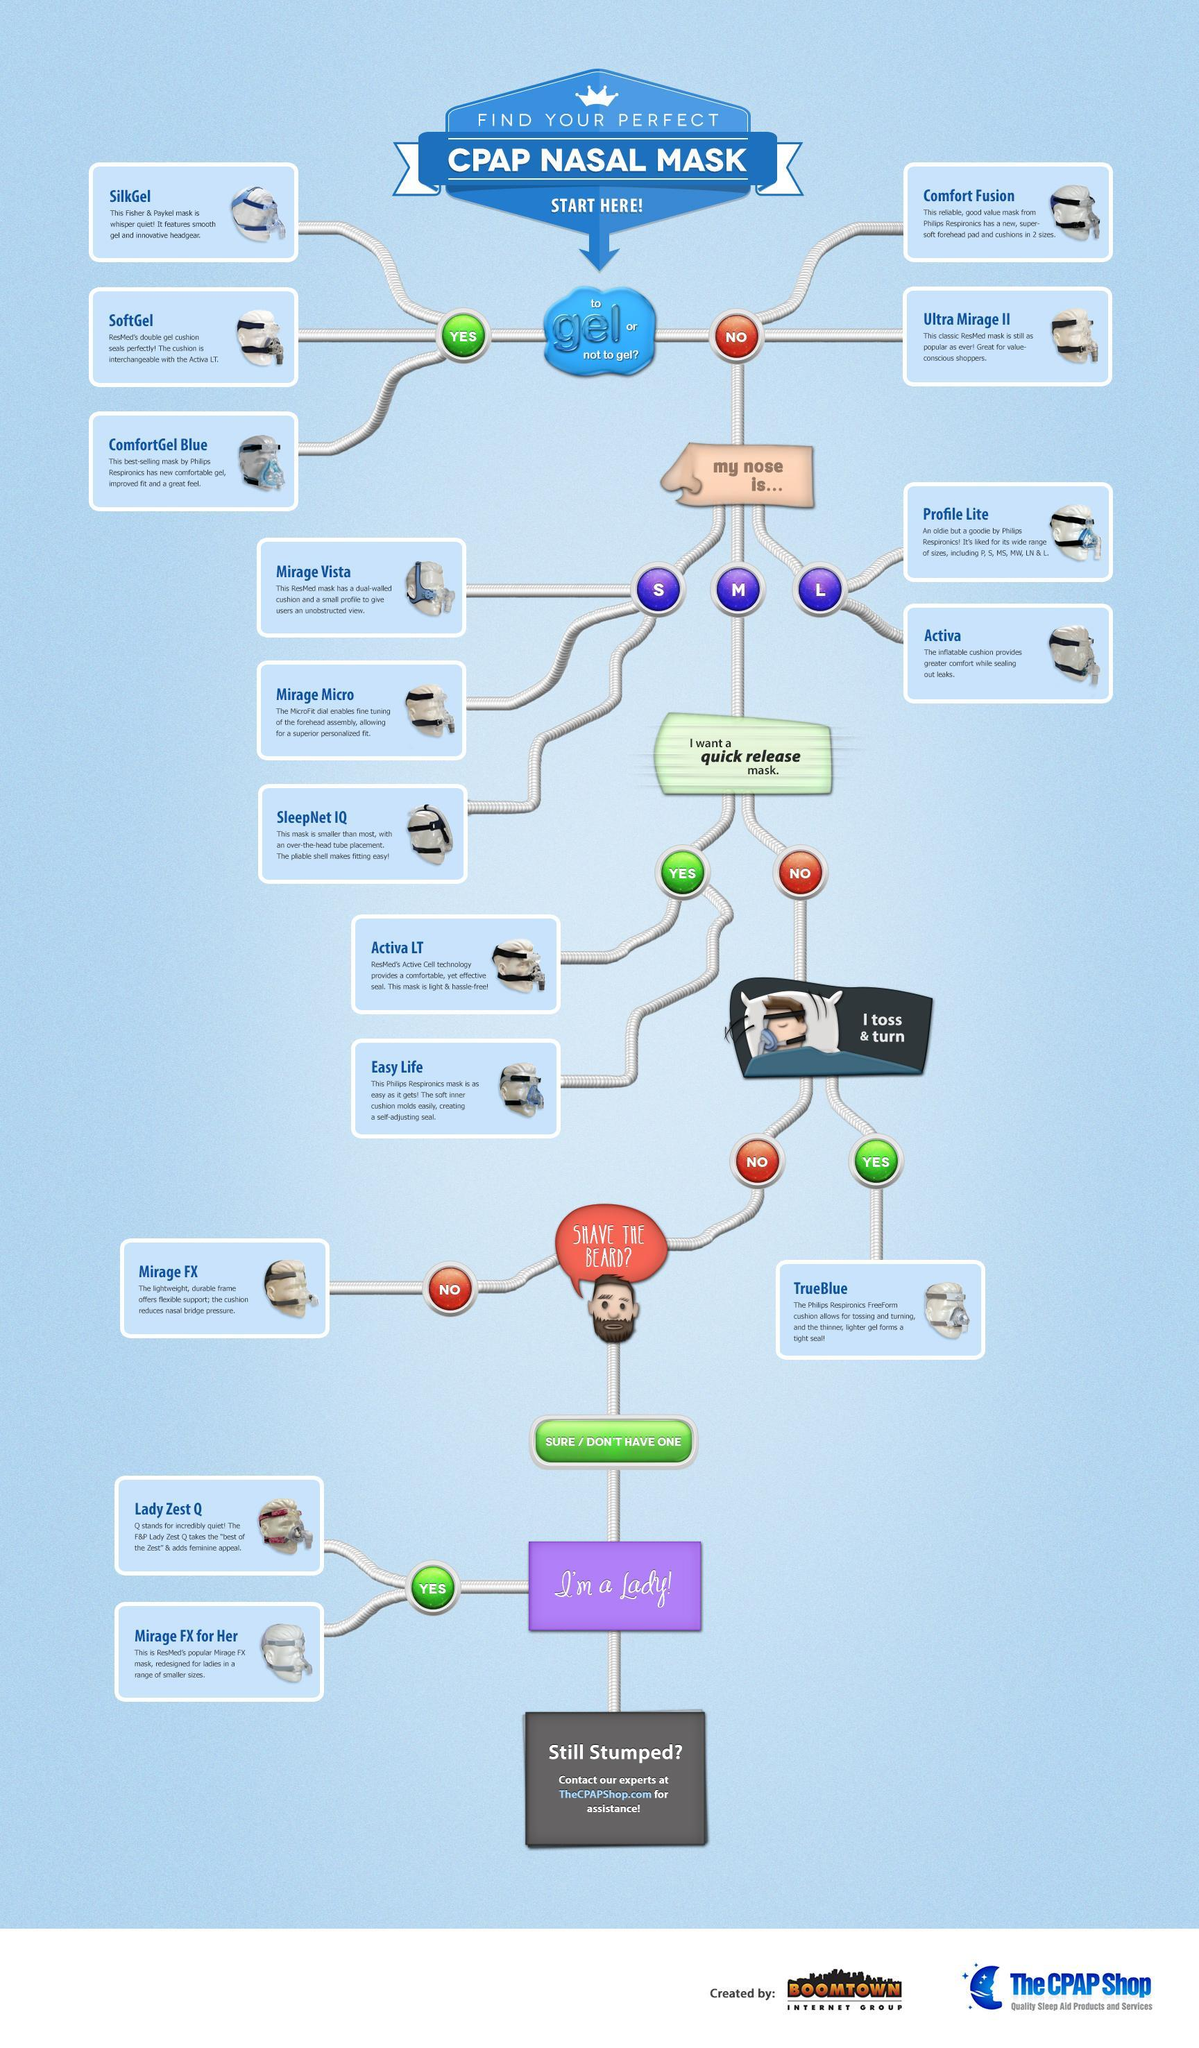Which mask listed in the infographic is smaller than most?
Answer the question with a short phrase. SleepNet IQ Which is the best mask for bearded people according to the infographic? Mirage FX Which options can people choose from if they wand a quick release mask? Activa LT,Easy Life Which masks are meant for women according to the infographic? Lady Zest Q,Mirage FX for her Which is the best mask for people who toss and turn while asleep? TrueBlue What are the options for people who do not want gel and have bigger noses? Profile Lite,Activa How many options are there for CPAP Nasal Mask without gel? 2 How many options are there for CPAP Nasal Mask with gel? 3 